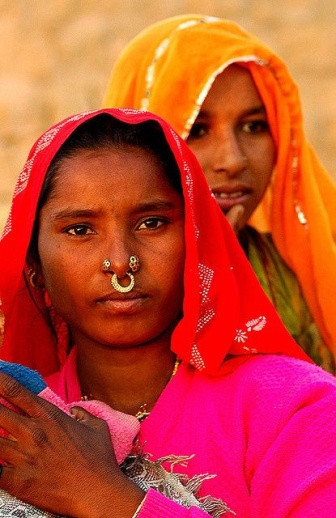Describe the following image. In the image, there are two women standing in front of a sandy background, embodying a rich cultural heritage. Both women are beautifully adorned in traditional Indian attire. The woman in the foreground wears a vibrant pink sari, intricately decorated with silver embroidery. Her traditional look is complemented by a striking gold nose ring. The background features another woman dressed in an orange sari and a gold headscarf. The bright colors of their clothing create a vivid contrast against the sandy backdrop, highlighting the cultural richness and tradition captured in this moment. 